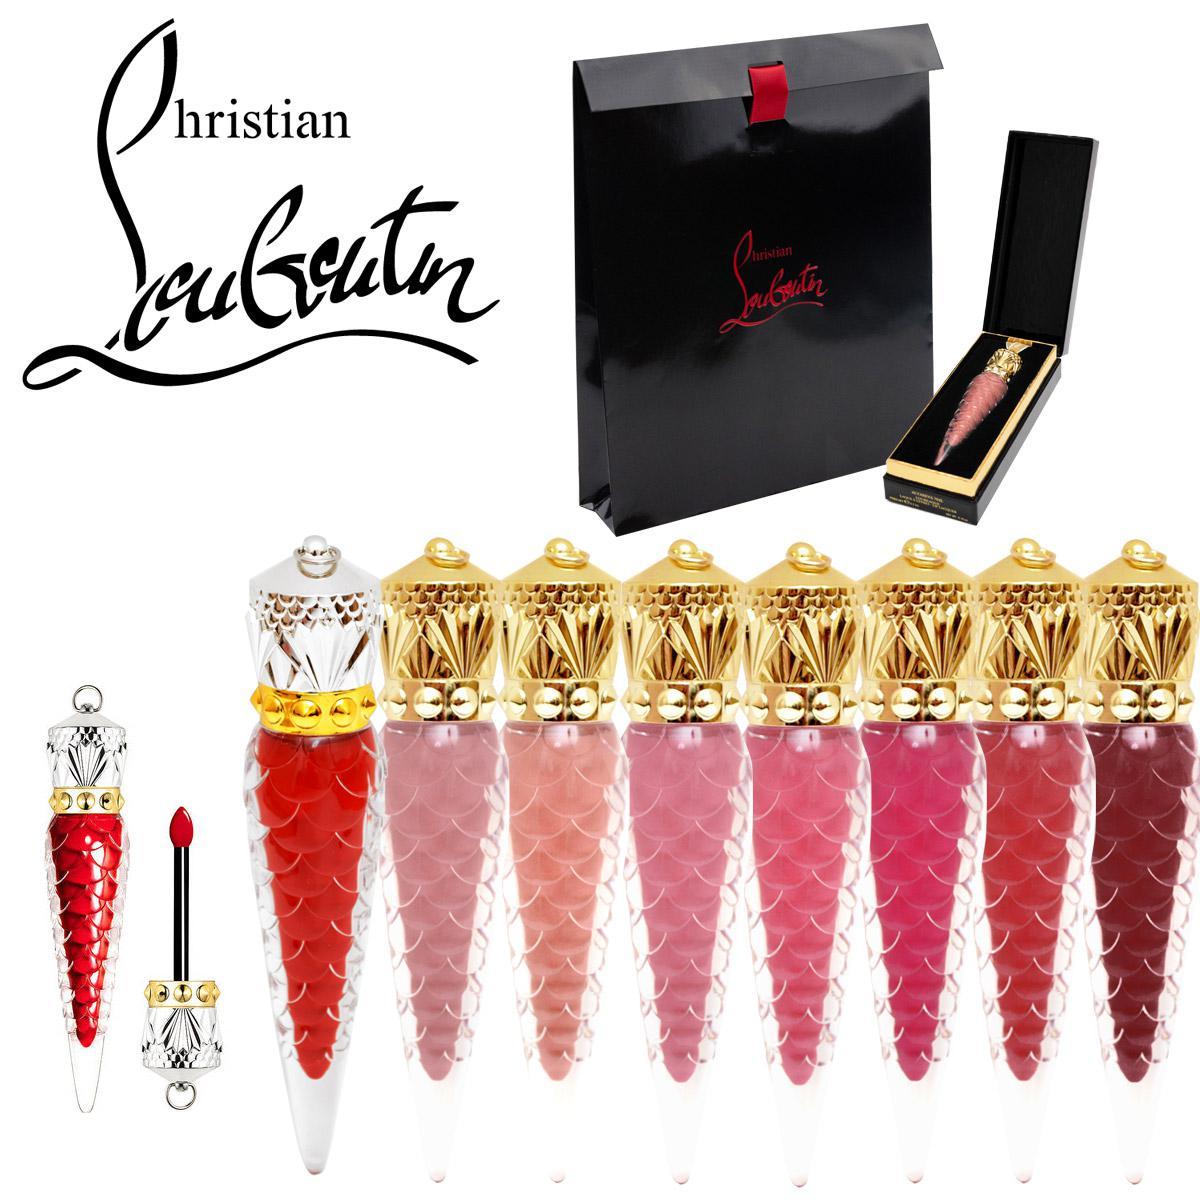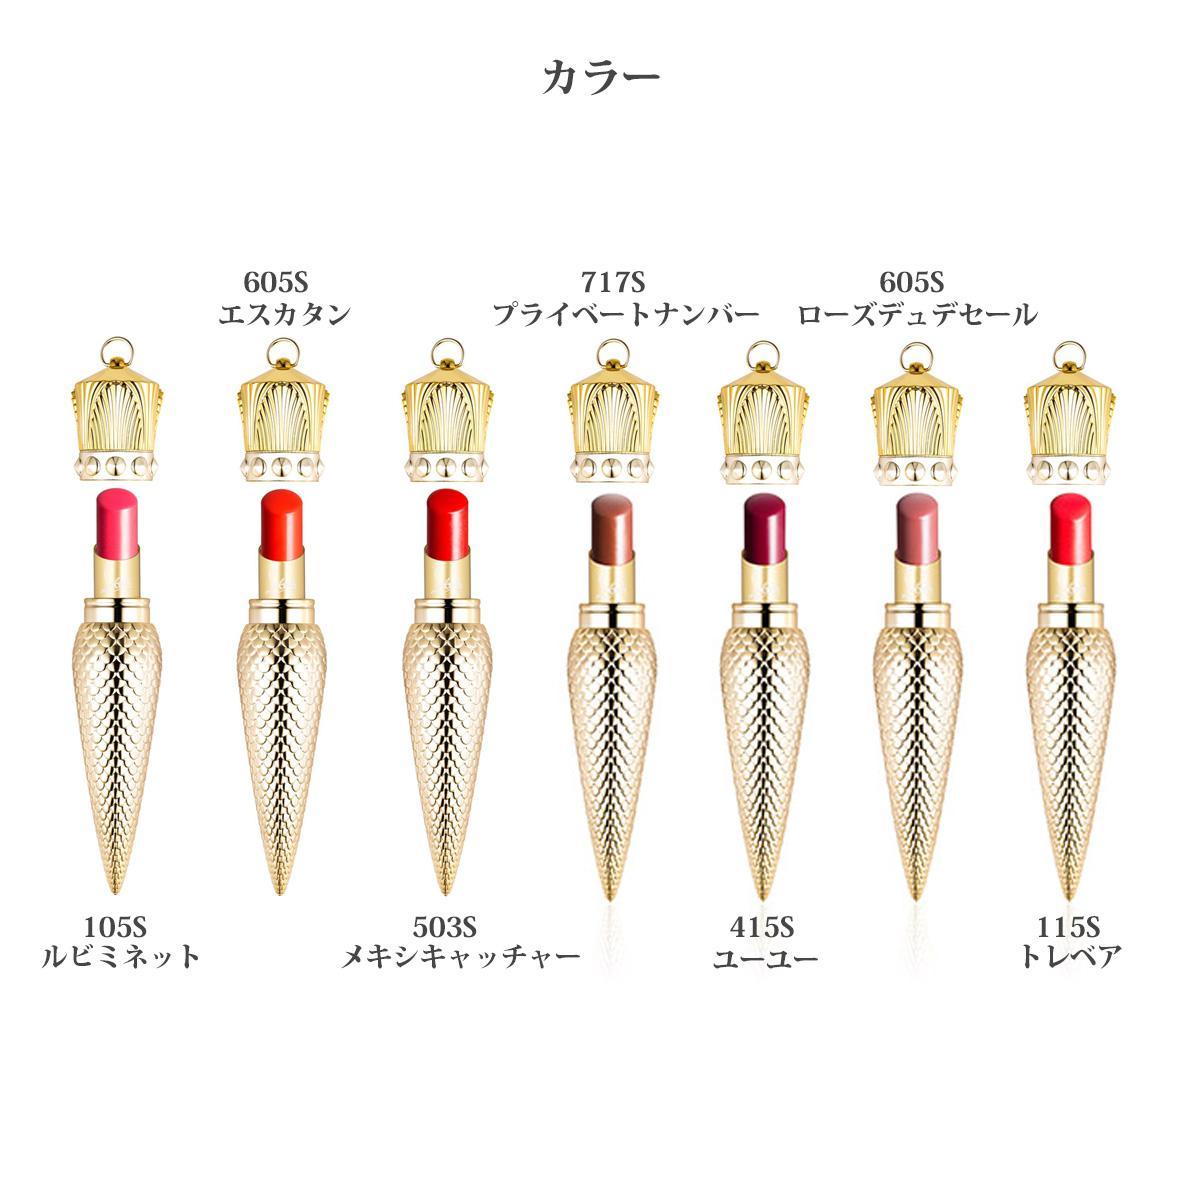The first image is the image on the left, the second image is the image on the right. Analyze the images presented: Is the assertion "An image shows at least eight ornament-shaped lipsticks in various shades." valid? Answer yes or no. Yes. The first image is the image on the left, the second image is the image on the right. Considering the images on both sides, is "a wand from lipglosss has a gold top with ribbon attached" valid? Answer yes or no. No. The first image is the image on the left, the second image is the image on the right. For the images shown, is this caption "One of the two images shows only one object; an open lip balm, with applicator." true? Answer yes or no. No. The first image is the image on the left, the second image is the image on the right. For the images shown, is this caption "There are at least five cone shaped lipstick containers in the image on the left." true? Answer yes or no. Yes. 